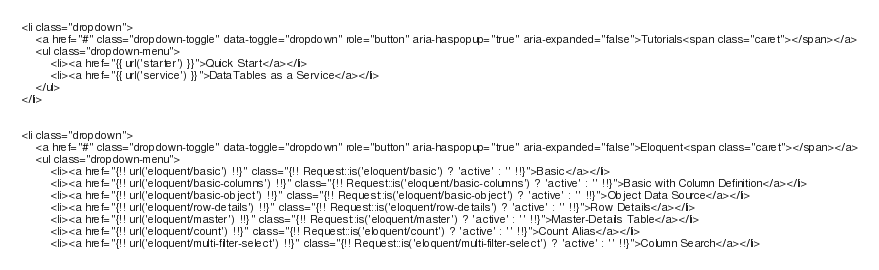Convert code to text. <code><loc_0><loc_0><loc_500><loc_500><_PHP_><li class="dropdown">
    <a href="#" class="dropdown-toggle" data-toggle="dropdown" role="button" aria-haspopup="true" aria-expanded="false">Tutorials<span class="caret"></span></a>
    <ul class="dropdown-menu">
        <li><a href="{{ url('starter') }}">Quick Start</a></li>
        <li><a href="{{ url('service') }}">DataTables as a Service</a></li>
    </ul>
</li>


<li class="dropdown">
	<a href="#" class="dropdown-toggle" data-toggle="dropdown" role="button" aria-haspopup="true" aria-expanded="false">Eloquent<span class="caret"></span></a>
	<ul class="dropdown-menu">
		<li><a href="{!! url('eloquent/basic') !!}" class="{!! Request::is('eloquent/basic') ? 'active' : '' !!}">Basic</a></li>
		<li><a href="{!! url('eloquent/basic-columns') !!}" class="{!! Request::is('eloquent/basic-columns') ? 'active' : '' !!}">Basic with Column Definition</a></li>
		<li><a href="{!! url('eloquent/basic-object') !!}" class="{!! Request::is('eloquent/basic-object') ? 'active' : '' !!}">Object Data Source</a></li>
		<li><a href="{!! url('eloquent/row-details') !!}" class="{!! Request::is('eloquent/row-details') ? 'active' : '' !!}">Row Details</a></li>
		<li><a href="{!! url('eloquent/master') !!}" class="{!! Request::is('eloquent/master') ? 'active' : '' !!}">Master-Details Table</a></li>
		<li><a href="{!! url('eloquent/count') !!}" class="{!! Request::is('eloquent/count') ? 'active' : '' !!}">Count Alias</a></li>
		<li><a href="{!! url('eloquent/multi-filter-select') !!}" class="{!! Request::is('eloquent/multi-filter-select') ? 'active' : '' !!}">Column Search</a></li></code> 